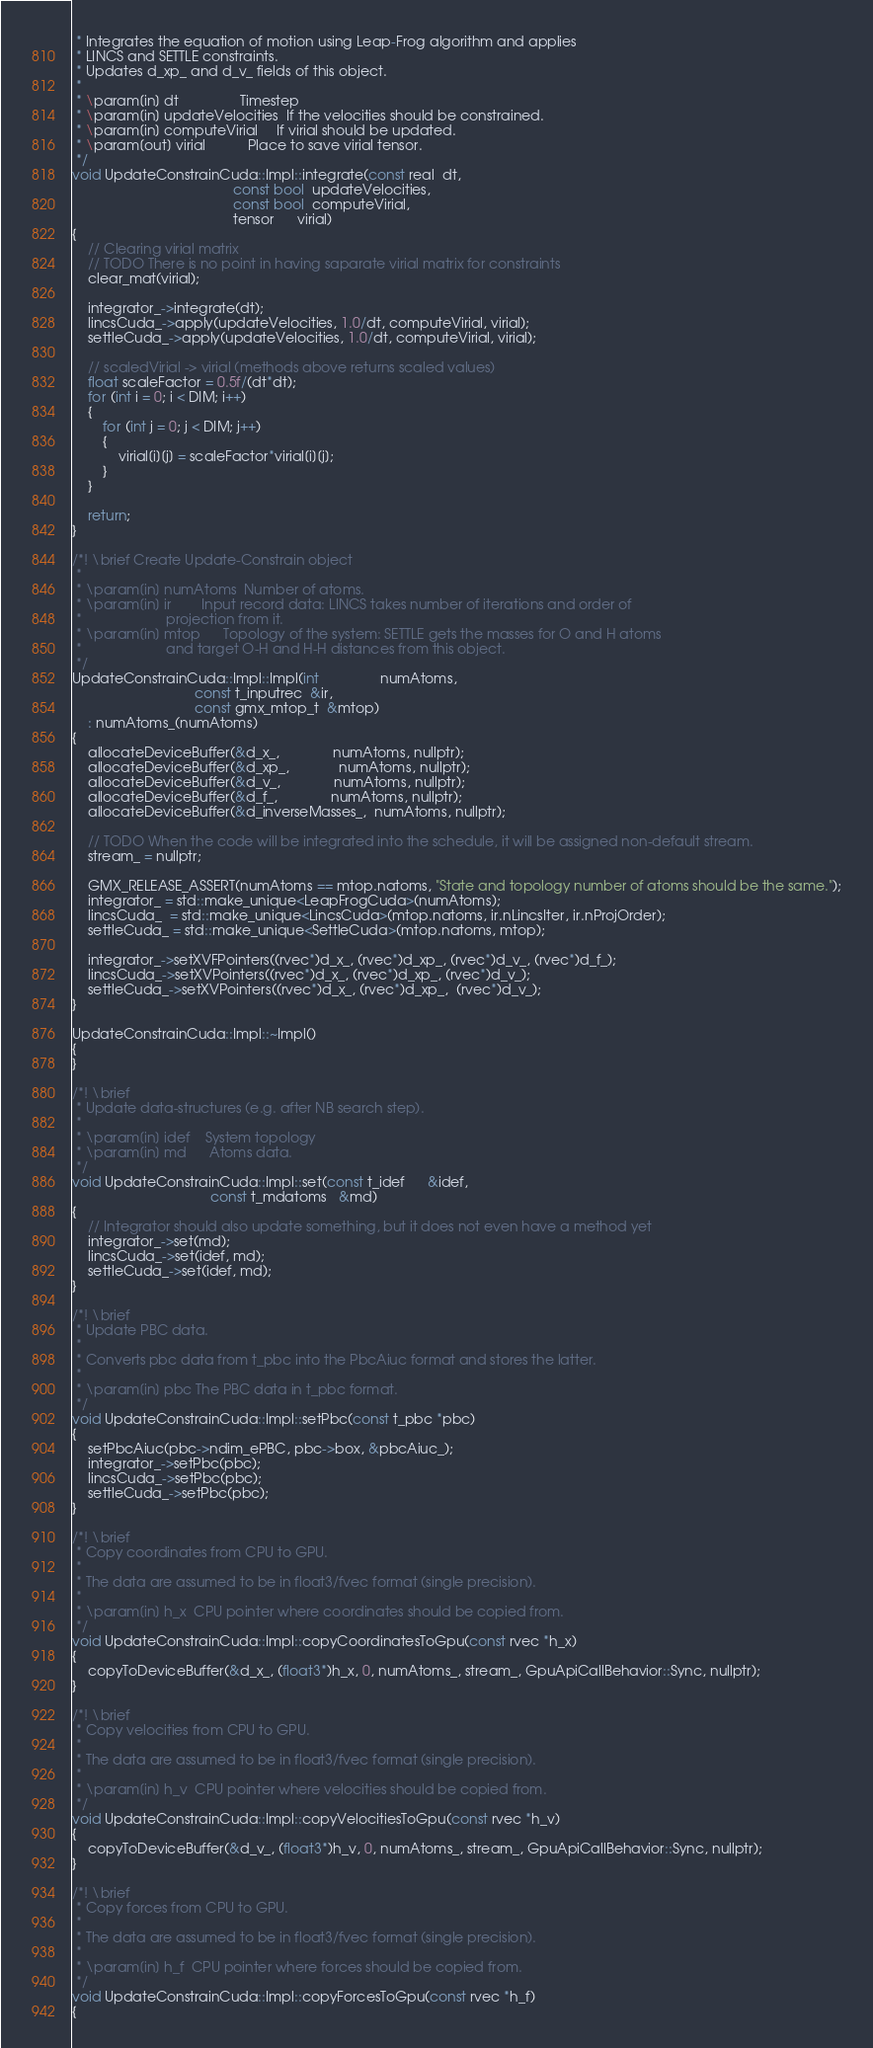Convert code to text. <code><loc_0><loc_0><loc_500><loc_500><_Cuda_> * Integrates the equation of motion using Leap-Frog algorithm and applies
 * LINCS and SETTLE constraints.
 * Updates d_xp_ and d_v_ fields of this object.
 *
 * \param[in] dt                Timestep
 * \param[in] updateVelocities  If the velocities should be constrained.
 * \param[in] computeVirial     If virial should be updated.
 * \param[out] virial           Place to save virial tensor.
 */
void UpdateConstrainCuda::Impl::integrate(const real  dt,
                                          const bool  updateVelocities,
                                          const bool  computeVirial,
                                          tensor      virial)
{
    // Clearing virial matrix
    // TODO There is no point in having saparate virial matrix for constraints
    clear_mat(virial);

    integrator_->integrate(dt);
    lincsCuda_->apply(updateVelocities, 1.0/dt, computeVirial, virial);
    settleCuda_->apply(updateVelocities, 1.0/dt, computeVirial, virial);

    // scaledVirial -> virial (methods above returns scaled values)
    float scaleFactor = 0.5f/(dt*dt);
    for (int i = 0; i < DIM; i++)
    {
        for (int j = 0; j < DIM; j++)
        {
            virial[i][j] = scaleFactor*virial[i][j];
        }
    }

    return;
}

/*! \brief Create Update-Constrain object
 *
 * \param[in] numAtoms  Number of atoms.
 * \param[in] ir        Input record data: LINCS takes number of iterations and order of
 *                      projection from it.
 * \param[in] mtop      Topology of the system: SETTLE gets the masses for O and H atoms
 *                      and target O-H and H-H distances from this object.
 */
UpdateConstrainCuda::Impl::Impl(int                numAtoms,
                                const t_inputrec  &ir,
                                const gmx_mtop_t  &mtop)
    : numAtoms_(numAtoms)
{
    allocateDeviceBuffer(&d_x_,              numAtoms, nullptr);
    allocateDeviceBuffer(&d_xp_,             numAtoms, nullptr);
    allocateDeviceBuffer(&d_v_,              numAtoms, nullptr);
    allocateDeviceBuffer(&d_f_,              numAtoms, nullptr);
    allocateDeviceBuffer(&d_inverseMasses_,  numAtoms, nullptr);

    // TODO When the code will be integrated into the schedule, it will be assigned non-default stream.
    stream_ = nullptr;

    GMX_RELEASE_ASSERT(numAtoms == mtop.natoms, "State and topology number of atoms should be the same.");
    integrator_ = std::make_unique<LeapFrogCuda>(numAtoms);
    lincsCuda_  = std::make_unique<LincsCuda>(mtop.natoms, ir.nLincsIter, ir.nProjOrder);
    settleCuda_ = std::make_unique<SettleCuda>(mtop.natoms, mtop);

    integrator_->setXVFPointers((rvec*)d_x_, (rvec*)d_xp_, (rvec*)d_v_, (rvec*)d_f_);
    lincsCuda_->setXVPointers((rvec*)d_x_, (rvec*)d_xp_, (rvec*)d_v_);
    settleCuda_->setXVPointers((rvec*)d_x_, (rvec*)d_xp_,  (rvec*)d_v_);
}

UpdateConstrainCuda::Impl::~Impl()
{
}

/*! \brief
 * Update data-structures (e.g. after NB search step).
 *
 * \param[in] idef    System topology
 * \param[in] md      Atoms data.
 */
void UpdateConstrainCuda::Impl::set(const t_idef      &idef,
                                    const t_mdatoms   &md)
{
    // Integrator should also update something, but it does not even have a method yet
    integrator_->set(md);
    lincsCuda_->set(idef, md);
    settleCuda_->set(idef, md);
}

/*! \brief
 * Update PBC data.
 *
 * Converts pbc data from t_pbc into the PbcAiuc format and stores the latter.
 *
 * \param[in] pbc The PBC data in t_pbc format.
 */
void UpdateConstrainCuda::Impl::setPbc(const t_pbc *pbc)
{
    setPbcAiuc(pbc->ndim_ePBC, pbc->box, &pbcAiuc_);
    integrator_->setPbc(pbc);
    lincsCuda_->setPbc(pbc);
    settleCuda_->setPbc(pbc);
}

/*! \brief
 * Copy coordinates from CPU to GPU.
 *
 * The data are assumed to be in float3/fvec format (single precision).
 *
 * \param[in] h_x  CPU pointer where coordinates should be copied from.
 */
void UpdateConstrainCuda::Impl::copyCoordinatesToGpu(const rvec *h_x)
{
    copyToDeviceBuffer(&d_x_, (float3*)h_x, 0, numAtoms_, stream_, GpuApiCallBehavior::Sync, nullptr);
}

/*! \brief
 * Copy velocities from CPU to GPU.
 *
 * The data are assumed to be in float3/fvec format (single precision).
 *
 * \param[in] h_v  CPU pointer where velocities should be copied from.
 */
void UpdateConstrainCuda::Impl::copyVelocitiesToGpu(const rvec *h_v)
{
    copyToDeviceBuffer(&d_v_, (float3*)h_v, 0, numAtoms_, stream_, GpuApiCallBehavior::Sync, nullptr);
}

/*! \brief
 * Copy forces from CPU to GPU.
 *
 * The data are assumed to be in float3/fvec format (single precision).
 *
 * \param[in] h_f  CPU pointer where forces should be copied from.
 */
void UpdateConstrainCuda::Impl::copyForcesToGpu(const rvec *h_f)
{</code> 